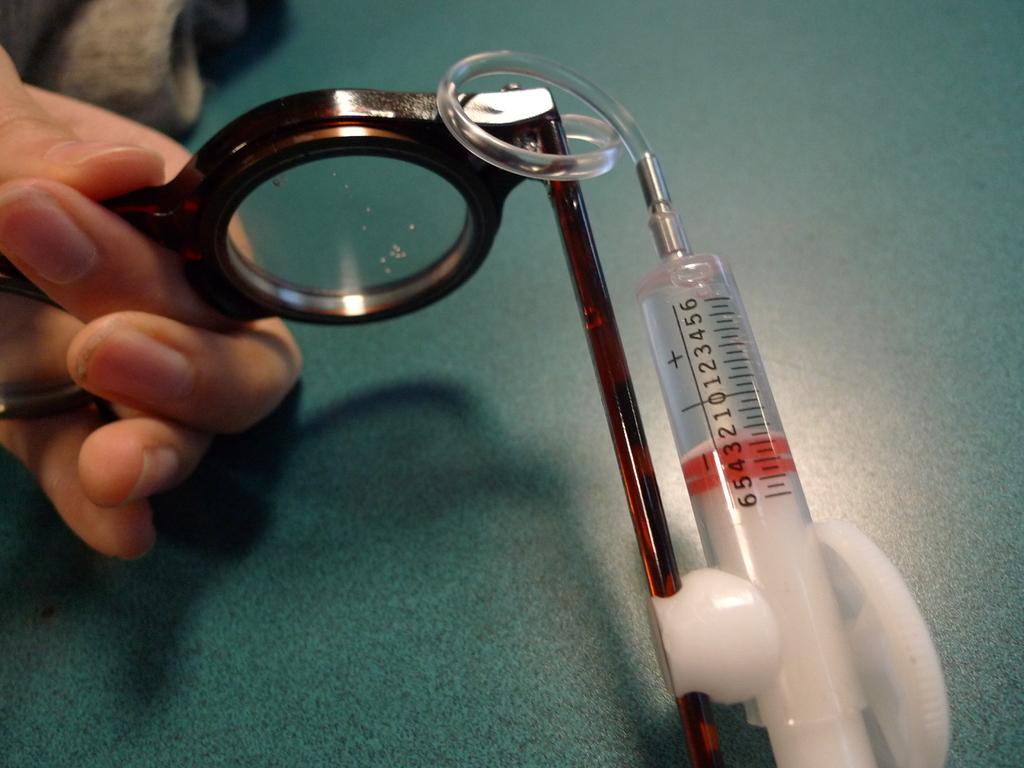Does this have negative number readings?
Keep it short and to the point. Yes. What is the last number printed on the syringe?
Your answer should be very brief. 6. 